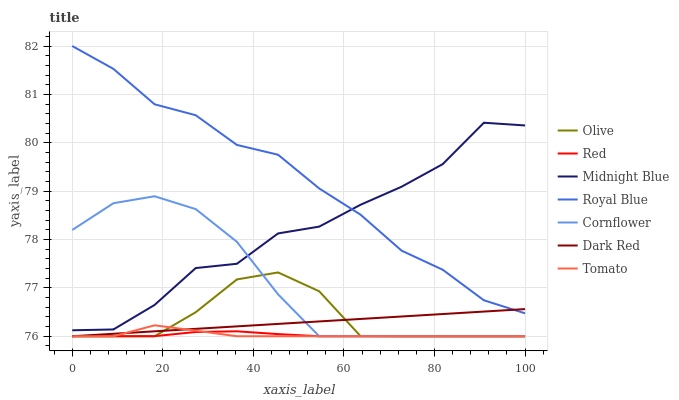Does Red have the minimum area under the curve?
Answer yes or no. Yes. Does Royal Blue have the maximum area under the curve?
Answer yes or no. Yes. Does Cornflower have the minimum area under the curve?
Answer yes or no. No. Does Cornflower have the maximum area under the curve?
Answer yes or no. No. Is Dark Red the smoothest?
Answer yes or no. Yes. Is Midnight Blue the roughest?
Answer yes or no. Yes. Is Cornflower the smoothest?
Answer yes or no. No. Is Cornflower the roughest?
Answer yes or no. No. Does Tomato have the lowest value?
Answer yes or no. Yes. Does Midnight Blue have the lowest value?
Answer yes or no. No. Does Royal Blue have the highest value?
Answer yes or no. Yes. Does Cornflower have the highest value?
Answer yes or no. No. Is Cornflower less than Royal Blue?
Answer yes or no. Yes. Is Royal Blue greater than Red?
Answer yes or no. Yes. Does Royal Blue intersect Dark Red?
Answer yes or no. Yes. Is Royal Blue less than Dark Red?
Answer yes or no. No. Is Royal Blue greater than Dark Red?
Answer yes or no. No. Does Cornflower intersect Royal Blue?
Answer yes or no. No. 